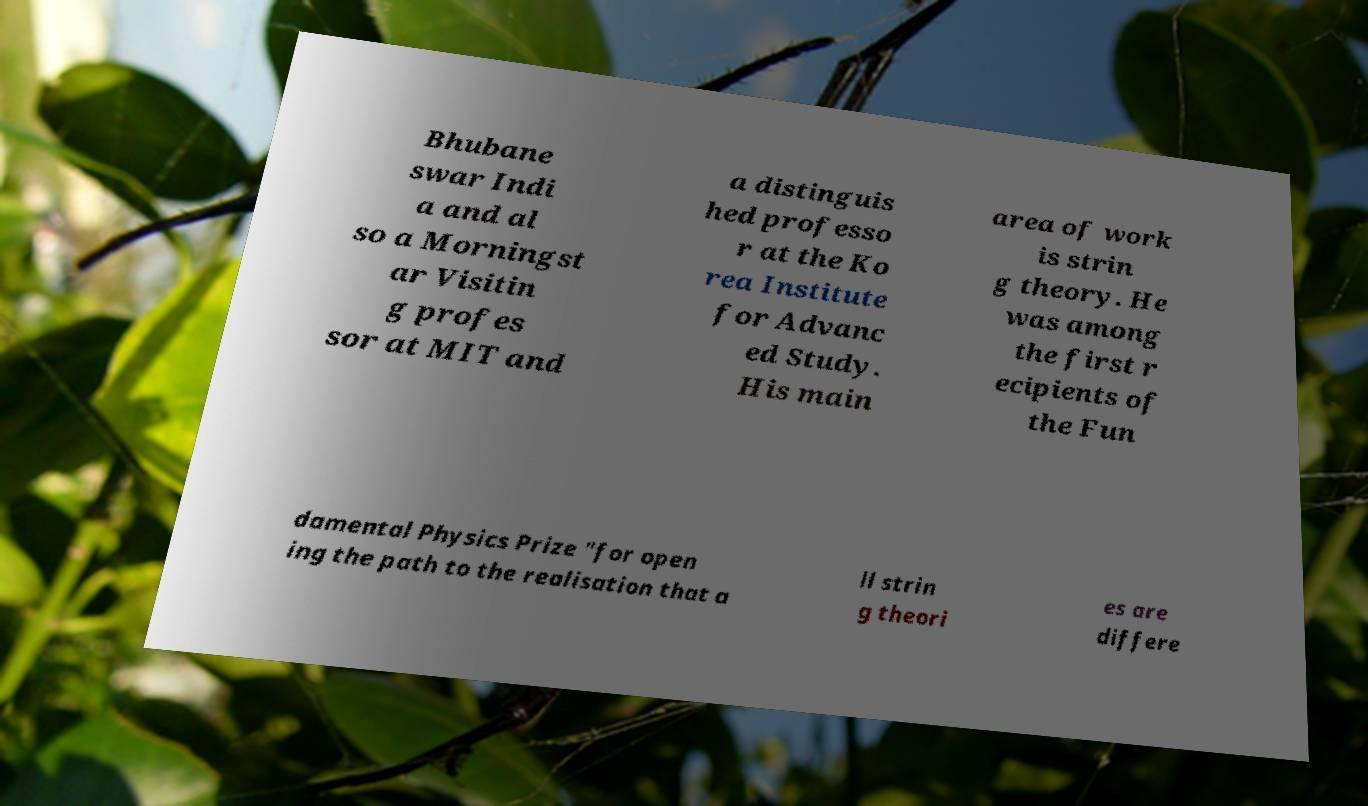Can you read and provide the text displayed in the image?This photo seems to have some interesting text. Can you extract and type it out for me? Bhubane swar Indi a and al so a Morningst ar Visitin g profes sor at MIT and a distinguis hed professo r at the Ko rea Institute for Advanc ed Study. His main area of work is strin g theory. He was among the first r ecipients of the Fun damental Physics Prize "for open ing the path to the realisation that a ll strin g theori es are differe 